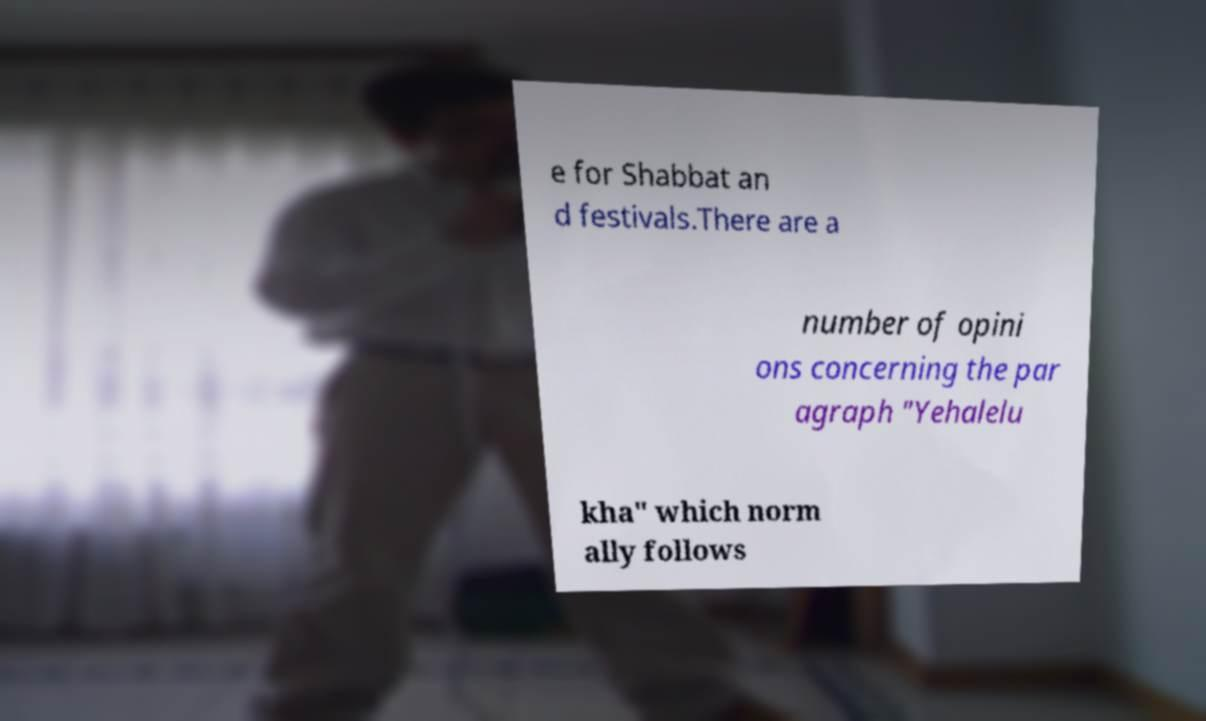Can you read and provide the text displayed in the image?This photo seems to have some interesting text. Can you extract and type it out for me? e for Shabbat an d festivals.There are a number of opini ons concerning the par agraph "Yehalelu kha" which norm ally follows 